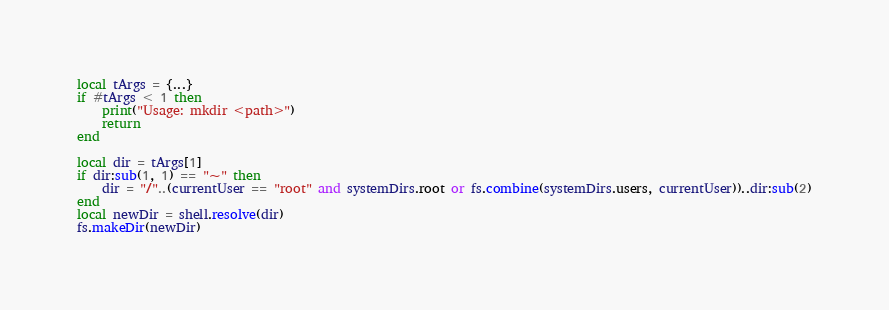<code> <loc_0><loc_0><loc_500><loc_500><_Lua_>local tArgs = {...}
if #tArgs < 1 then
	print("Usage: mkdir <path>")
	return
end

local dir = tArgs[1]
if dir:sub(1, 1) == "~" then
	dir = "/"..(currentUser == "root" and systemDirs.root or fs.combine(systemDirs.users, currentUser))..dir:sub(2)
end
local newDir = shell.resolve(dir)
fs.makeDir(newDir)</code> 